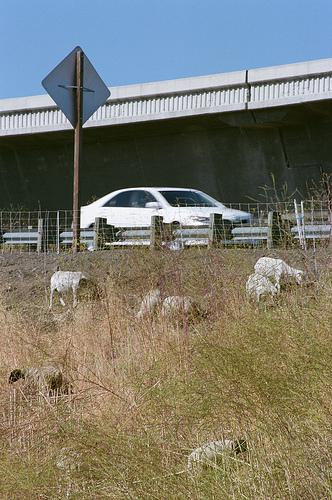Question: where is the car parked?
Choices:
A. The street.
B. The driveway.
C. The parking lot.
D. The garage.
Answer with the letter. Answer: A Question: what is green?
Choices:
A. The sign.
B. The grass.
C. The frog.
D. The leaves.
Answer with the letter. Answer: B Question: why is it so bright?
Choices:
A. No clouds.
B. Sun reflecting off the water.
C. It's noon.
D. Sunny.
Answer with the letter. Answer: D Question: what is in the grass?
Choices:
A. Animals.
B. People.
C. Flowers.
D. Trash.
Answer with the letter. Answer: A 